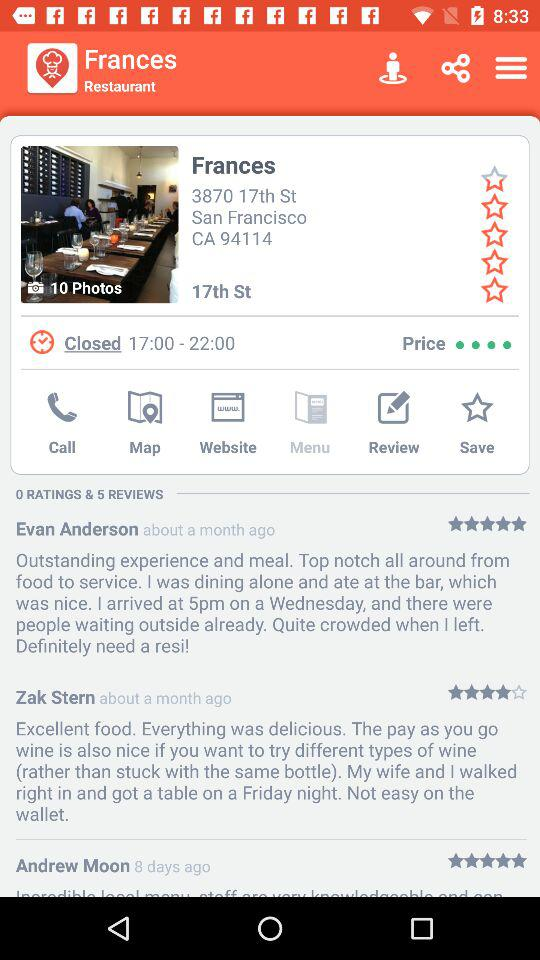What is the address of Frances? The address is 3870 17th St., San Francisco, CA 94114. 